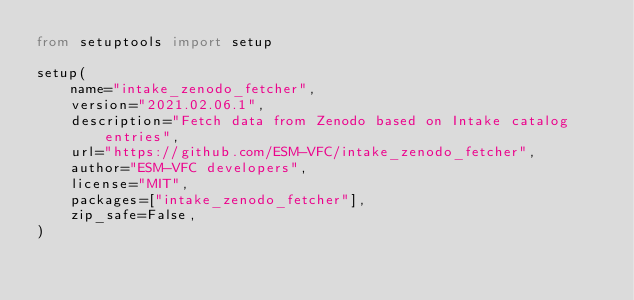Convert code to text. <code><loc_0><loc_0><loc_500><loc_500><_Python_>from setuptools import setup

setup(
    name="intake_zenodo_fetcher",
    version="2021.02.06.1",
    description="Fetch data from Zenodo based on Intake catalog entries",
    url="https://github.com/ESM-VFC/intake_zenodo_fetcher",
    author="ESM-VFC developers",
    license="MIT",
    packages=["intake_zenodo_fetcher"],
    zip_safe=False,
)
</code> 